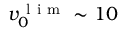Convert formula to latex. <formula><loc_0><loc_0><loc_500><loc_500>v _ { 0 } ^ { l i m } \sim 1 0</formula> 